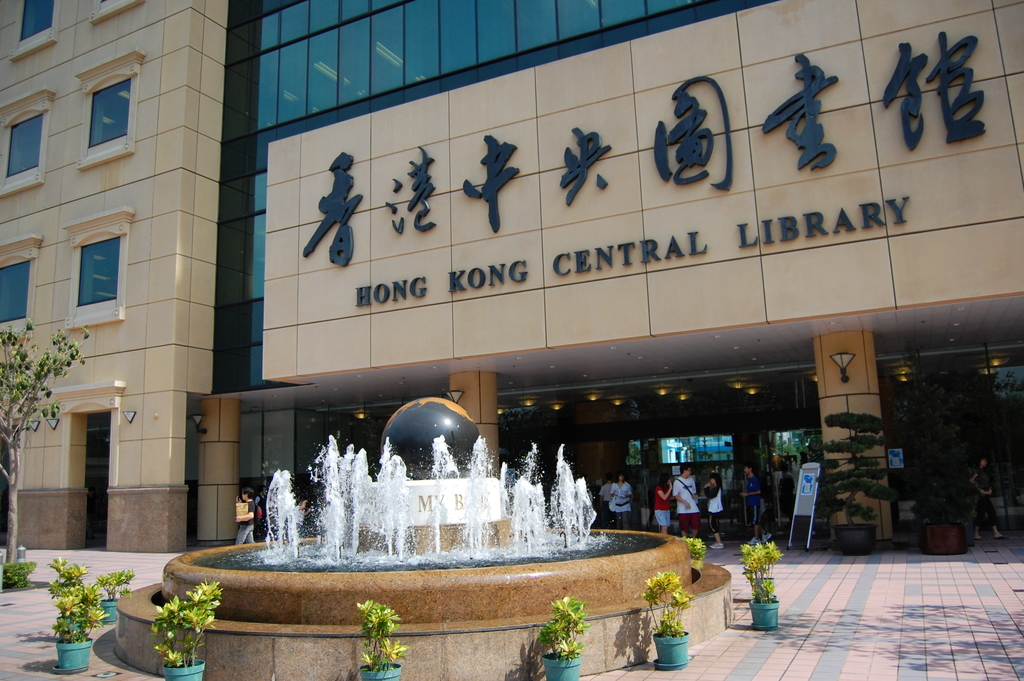Why is there a large sphere in the fountain in front of the library? The large sphere in the fountain serves both an aesthetic and symbolic purpose. As an art installation, it represents the global reach and universal appeal of knowledge and literature, underscoring the library's role in fostering cultural exchange and educational growth. Functionally, the sphere adds a dynamic visual element to the entrance, creating a welcoming and engaging atmosphere for visitors.  Does this sphere have a specific name or artist associated with it? The sphere does not have a specific name publicized nor is there a widely recognized artist attributed to its creation. It is likely a commissioned piece designed to integrate with the library's modern architecture and public space. The design aligns with the contemporary and inclusive ethos of the Hong Kong Central Library, emphasizing its commitment to being a central hub for community engagement and knowledge dissemination. 